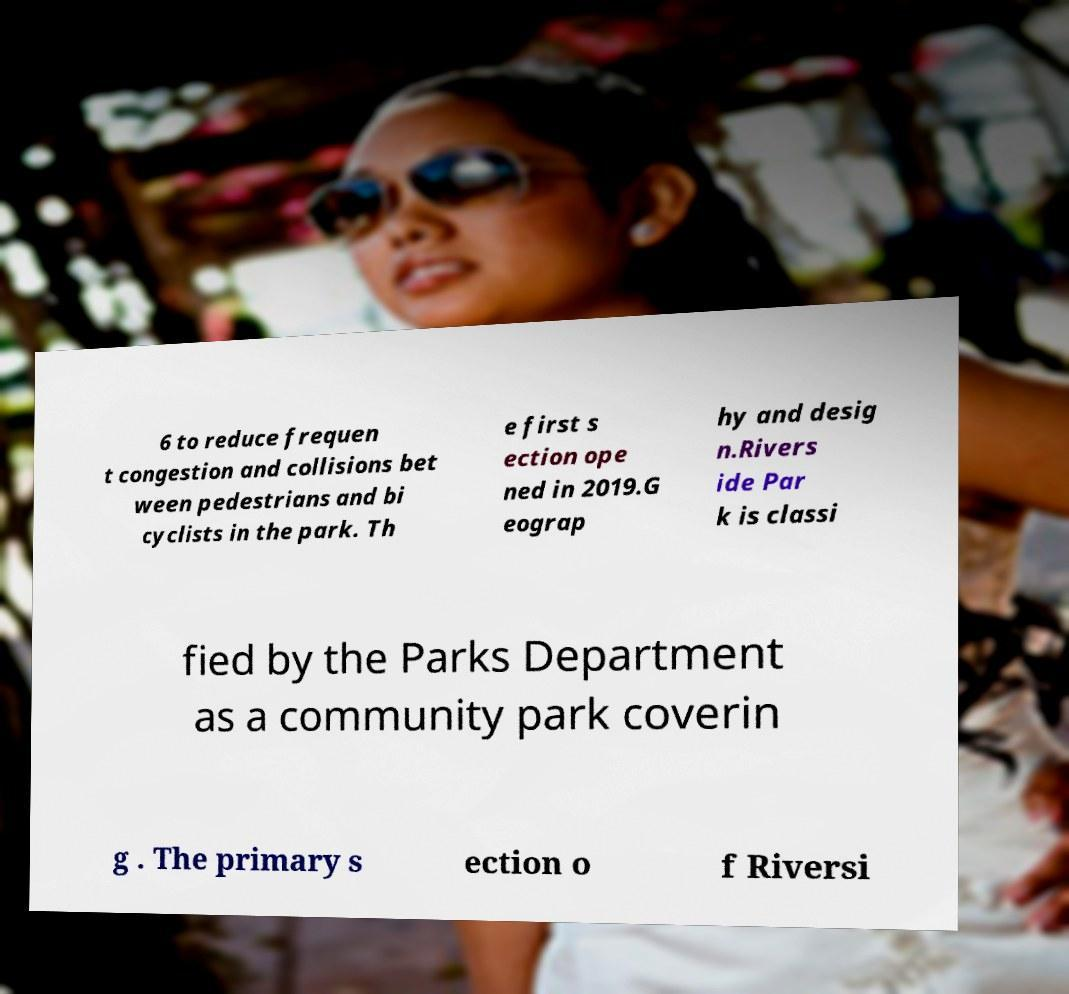Could you assist in decoding the text presented in this image and type it out clearly? 6 to reduce frequen t congestion and collisions bet ween pedestrians and bi cyclists in the park. Th e first s ection ope ned in 2019.G eograp hy and desig n.Rivers ide Par k is classi fied by the Parks Department as a community park coverin g . The primary s ection o f Riversi 